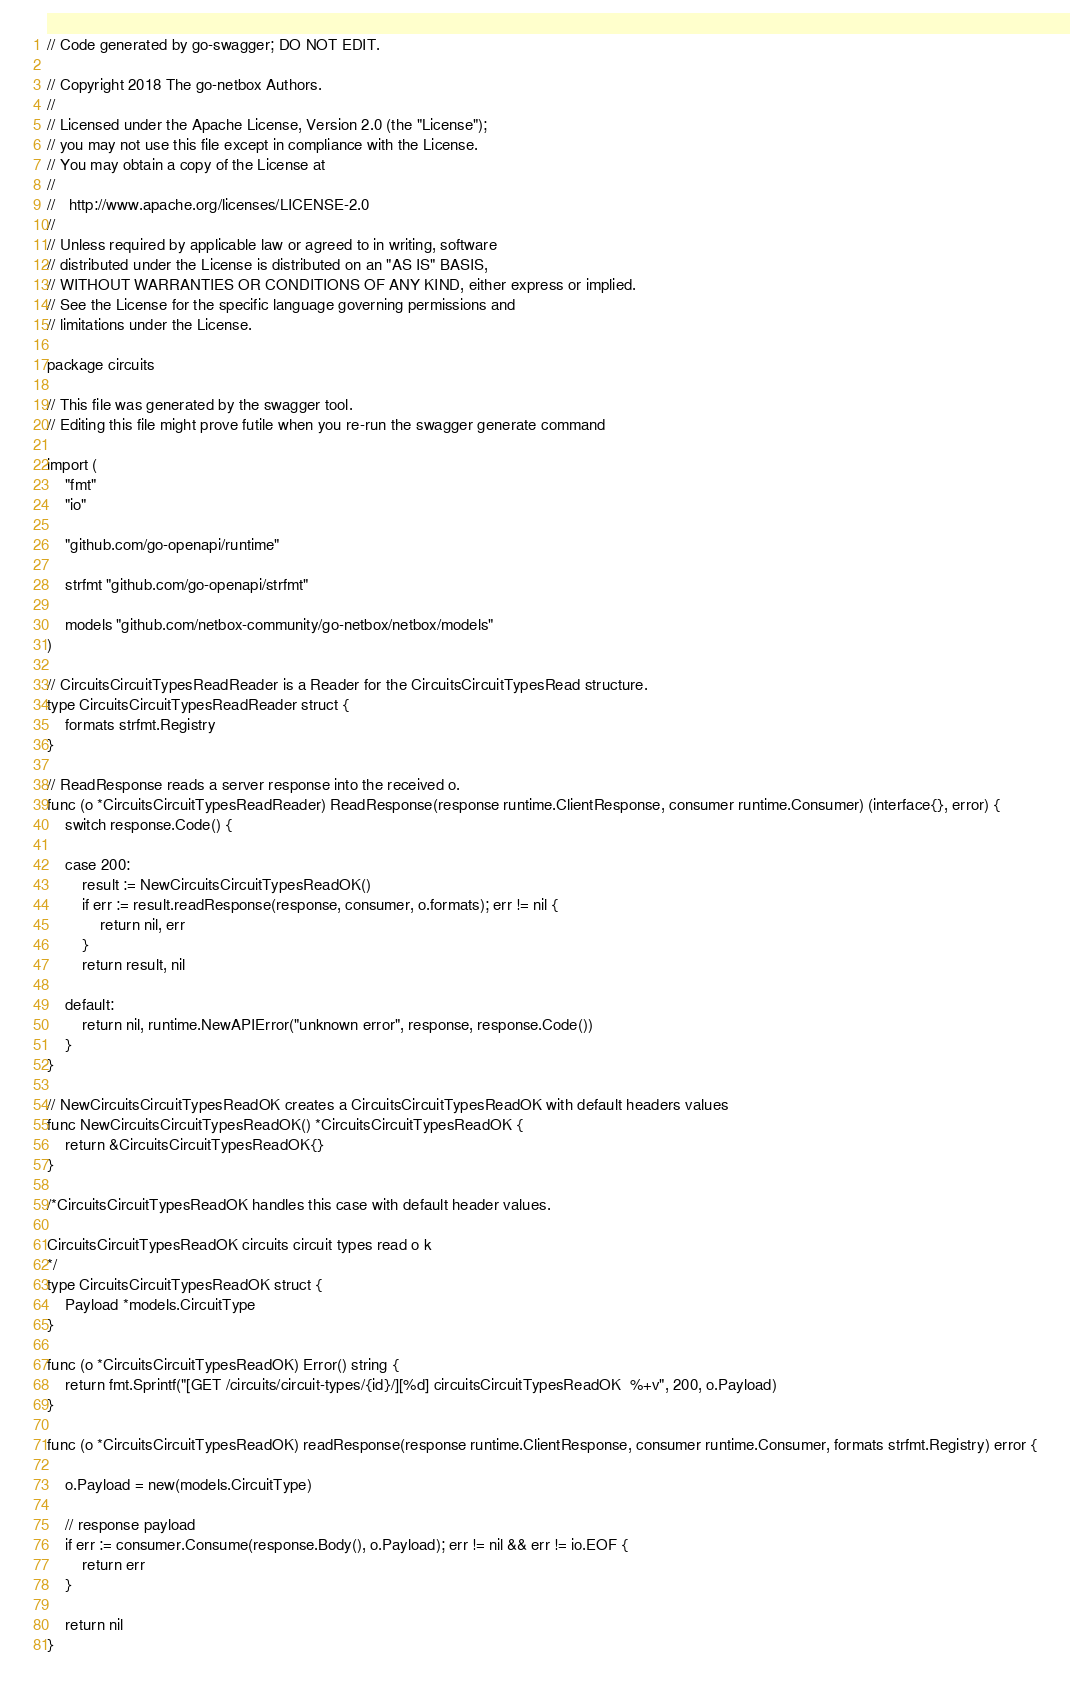Convert code to text. <code><loc_0><loc_0><loc_500><loc_500><_Go_>// Code generated by go-swagger; DO NOT EDIT.

// Copyright 2018 The go-netbox Authors.
//
// Licensed under the Apache License, Version 2.0 (the "License");
// you may not use this file except in compliance with the License.
// You may obtain a copy of the License at
//
//   http://www.apache.org/licenses/LICENSE-2.0
//
// Unless required by applicable law or agreed to in writing, software
// distributed under the License is distributed on an "AS IS" BASIS,
// WITHOUT WARRANTIES OR CONDITIONS OF ANY KIND, either express or implied.
// See the License for the specific language governing permissions and
// limitations under the License.

package circuits

// This file was generated by the swagger tool.
// Editing this file might prove futile when you re-run the swagger generate command

import (
	"fmt"
	"io"

	"github.com/go-openapi/runtime"

	strfmt "github.com/go-openapi/strfmt"

	models "github.com/netbox-community/go-netbox/netbox/models"
)

// CircuitsCircuitTypesReadReader is a Reader for the CircuitsCircuitTypesRead structure.
type CircuitsCircuitTypesReadReader struct {
	formats strfmt.Registry
}

// ReadResponse reads a server response into the received o.
func (o *CircuitsCircuitTypesReadReader) ReadResponse(response runtime.ClientResponse, consumer runtime.Consumer) (interface{}, error) {
	switch response.Code() {

	case 200:
		result := NewCircuitsCircuitTypesReadOK()
		if err := result.readResponse(response, consumer, o.formats); err != nil {
			return nil, err
		}
		return result, nil

	default:
		return nil, runtime.NewAPIError("unknown error", response, response.Code())
	}
}

// NewCircuitsCircuitTypesReadOK creates a CircuitsCircuitTypesReadOK with default headers values
func NewCircuitsCircuitTypesReadOK() *CircuitsCircuitTypesReadOK {
	return &CircuitsCircuitTypesReadOK{}
}

/*CircuitsCircuitTypesReadOK handles this case with default header values.

CircuitsCircuitTypesReadOK circuits circuit types read o k
*/
type CircuitsCircuitTypesReadOK struct {
	Payload *models.CircuitType
}

func (o *CircuitsCircuitTypesReadOK) Error() string {
	return fmt.Sprintf("[GET /circuits/circuit-types/{id}/][%d] circuitsCircuitTypesReadOK  %+v", 200, o.Payload)
}

func (o *CircuitsCircuitTypesReadOK) readResponse(response runtime.ClientResponse, consumer runtime.Consumer, formats strfmt.Registry) error {

	o.Payload = new(models.CircuitType)

	// response payload
	if err := consumer.Consume(response.Body(), o.Payload); err != nil && err != io.EOF {
		return err
	}

	return nil
}
</code> 